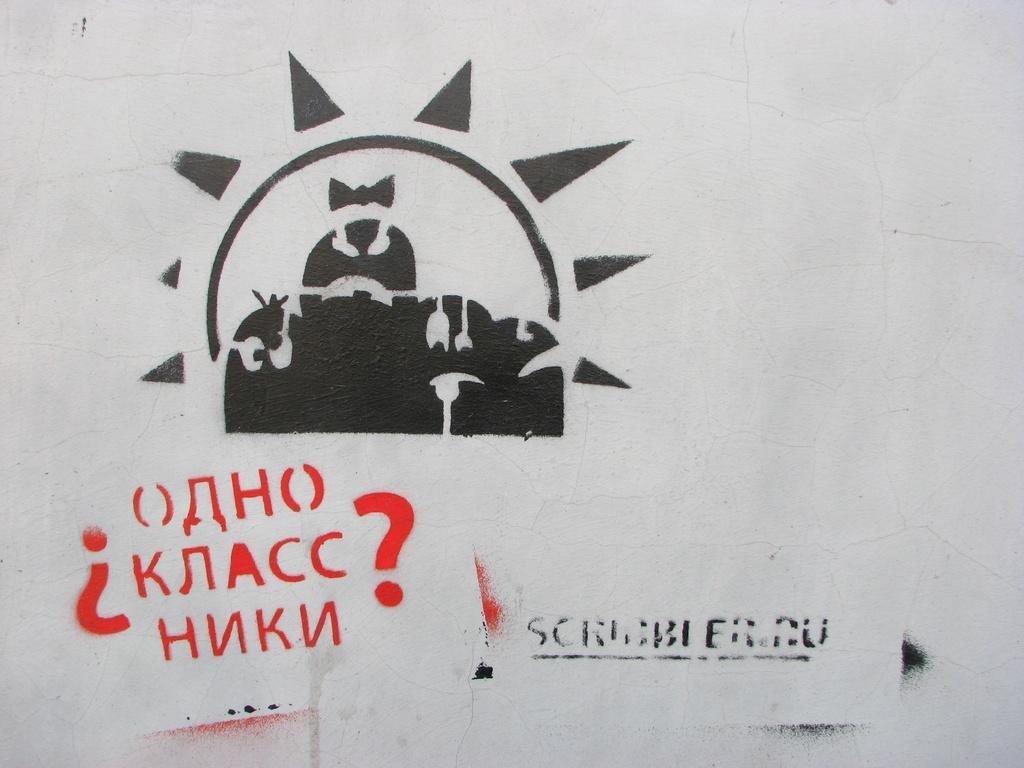How would you summarize this image in a sentence or two? In this image we can see a picture and text written on the wall. 